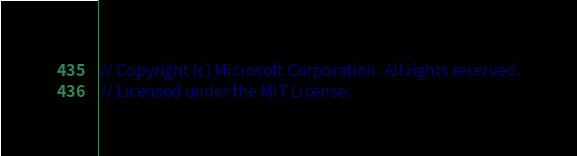Convert code to text. <code><loc_0><loc_0><loc_500><loc_500><_Java_>// Copyright (c) Microsoft Corporation. All rights reserved.
// Licensed under the MIT License.</code> 